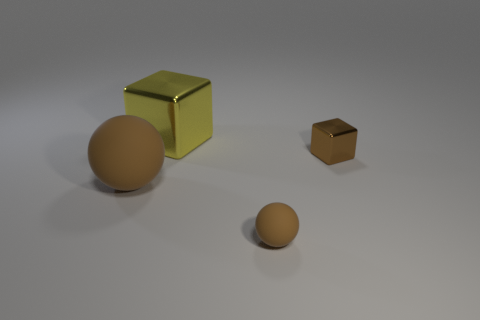Subtract all yellow balls. Subtract all purple cylinders. How many balls are left? 2 Subtract all blue blocks. How many blue balls are left? 0 Add 4 large objects. How many tiny browns exist? 0 Subtract all tiny yellow shiny blocks. Subtract all small metallic blocks. How many objects are left? 3 Add 2 brown metal objects. How many brown metal objects are left? 3 Add 2 small brown rubber objects. How many small brown rubber objects exist? 3 Add 3 tiny gray matte cylinders. How many objects exist? 7 Subtract all yellow blocks. How many blocks are left? 1 Subtract 0 red cylinders. How many objects are left? 4 How many brown balls must be subtracted to get 1 brown balls? 1 